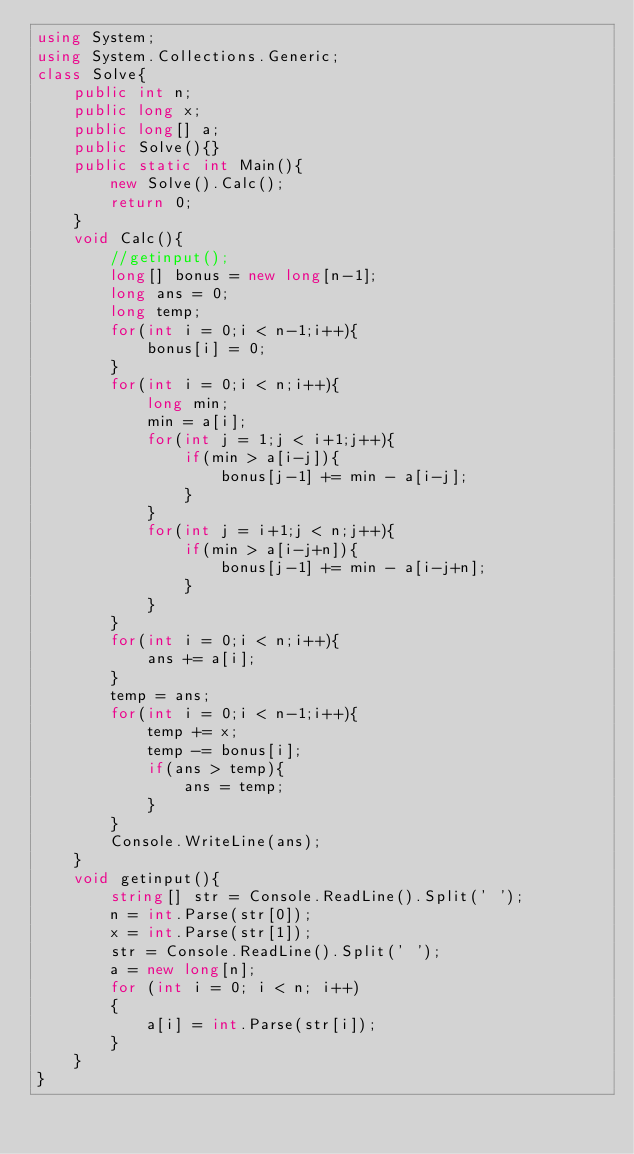<code> <loc_0><loc_0><loc_500><loc_500><_C#_>using System;
using System.Collections.Generic;
class Solve{
    public int n;
    public long x;
    public long[] a;
    public Solve(){}
    public static int Main(){
        new Solve().Calc();
        return 0;
    }
    void Calc(){
        //getinput();
        long[] bonus = new long[n-1];
        long ans = 0;
        long temp;
        for(int i = 0;i < n-1;i++){
            bonus[i] = 0;
        }
        for(int i = 0;i < n;i++){
            long min;
            min = a[i];
            for(int j = 1;j < i+1;j++){
                if(min > a[i-j]){
                    bonus[j-1] += min - a[i-j];
                }
            }
            for(int j = i+1;j < n;j++){
                if(min > a[i-j+n]){
                    bonus[j-1] += min - a[i-j+n];
                }
            }
        }
        for(int i = 0;i < n;i++){
            ans += a[i];
        }
        temp = ans;
        for(int i = 0;i < n-1;i++){
            temp += x;
            temp -= bonus[i];
            if(ans > temp){
                ans = temp;
            }
        }
        Console.WriteLine(ans);
    }
    void getinput(){
        string[] str = Console.ReadLine().Split(' ');
        n = int.Parse(str[0]);
        x = int.Parse(str[1]);
        str = Console.ReadLine().Split(' ');
        a = new long[n];
        for (int i = 0; i < n; i++)
        {
            a[i] = int.Parse(str[i]);
        }
    }    
}</code> 